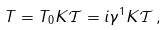Convert formula to latex. <formula><loc_0><loc_0><loc_500><loc_500>T = T _ { 0 } K \mathcal { T } = i \gamma ^ { 1 } K \mathcal { T } \, ,</formula> 